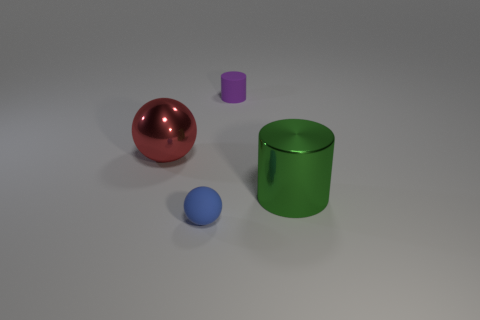Add 4 red shiny things. How many objects exist? 8 Subtract all big cyan things. Subtract all green objects. How many objects are left? 3 Add 1 tiny rubber balls. How many tiny rubber balls are left? 2 Add 3 brown balls. How many brown balls exist? 3 Subtract 0 yellow balls. How many objects are left? 4 